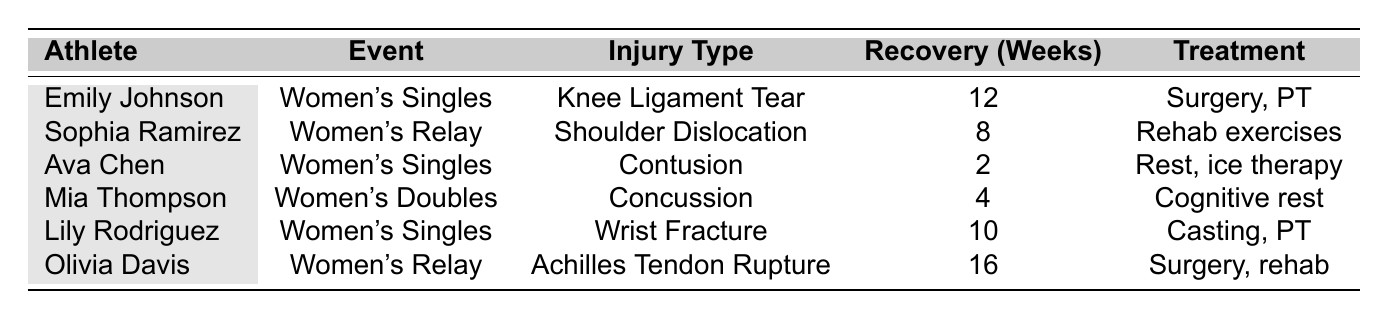What type of injury did Ava Chen sustain? Ava Chen's entry in the table specifies her injury type as "Contusion".
Answer: Contusion How many weeks is the recovery time for Emily Johnson's injury? The table indicates that Emily Johnson's recovery time is listed as 12 weeks.
Answer: 12 weeks Which athlete requires surgery as part of their treatment? By examining the table, it shows that both Emily Johnson and Olivia Davis require surgery as part of their treatment.
Answer: Emily Johnson, Olivia Davis What is the average recovery time for all the injuries listed? To find the average recovery time, we add the recovery times: (12 + 8 + 2 + 4 + 10 + 16) = 52 weeks. There are 6 athletes, so the average is 52/6 = 8.67 weeks.
Answer: 8.67 weeks Is there any athlete with a recovery time shorter than 5 weeks? The table mentions Ava Chen's recovery time as 2 weeks and Mia Thompson's as 4 weeks, which are both shorter than 5 weeks.
Answer: Yes How many athletes sustained injuries in the Women's Singles event? The table indicates Emily Johnson, Ava Chen, and Lily Rodriguez participated in the Women's Singles event, making it 3 athletes.
Answer: 3 athletes Which type of injury has the longest recovery time among the athletes? Checking the recovery times, Olivia Davis's Achilles Tendon Rupture has the longest recovery period of 16 weeks.
Answer: Achilles Tendon Rupture If Mia Thompson and Lily Rodriguez's recovery times are summed together, what is the total? Adding Mia Thompson's recovery time of 4 weeks to Lily Rodriguez's 10 weeks gives a total of 4 + 10 = 14 weeks.
Answer: 14 weeks What is the recovery time difference between the longest and shortest injury recovery times? The longest recovery time is 16 weeks (Olivia Davis) and the shortest is 2 weeks (Ava Chen). The difference is 16 - 2 = 14 weeks.
Answer: 14 weeks How many injuries listed occurred in November 2023? From the table, Emily Johnson's injury is on November 10, Mia Thompson's on November 20, and there are no other injuries listed in November, totaling 2 injuries.
Answer: 2 injuries 